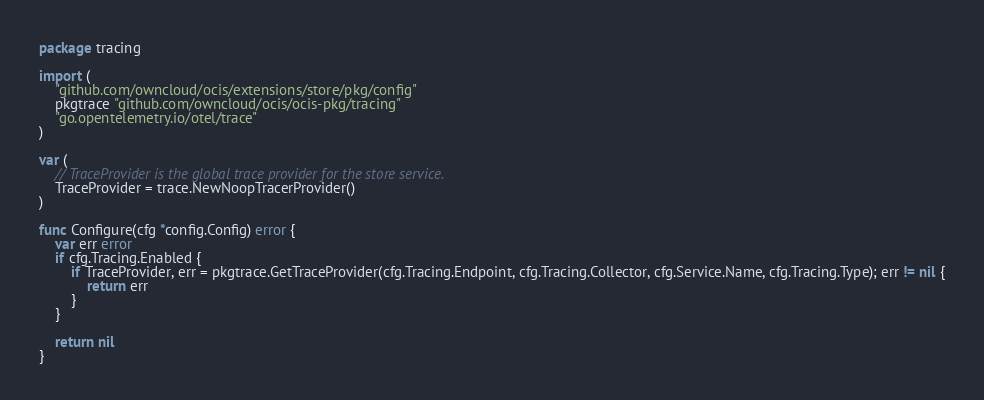Convert code to text. <code><loc_0><loc_0><loc_500><loc_500><_Go_>package tracing

import (
	"github.com/owncloud/ocis/extensions/store/pkg/config"
	pkgtrace "github.com/owncloud/ocis/ocis-pkg/tracing"
	"go.opentelemetry.io/otel/trace"
)

var (
	// TraceProvider is the global trace provider for the store service.
	TraceProvider = trace.NewNoopTracerProvider()
)

func Configure(cfg *config.Config) error {
	var err error
	if cfg.Tracing.Enabled {
		if TraceProvider, err = pkgtrace.GetTraceProvider(cfg.Tracing.Endpoint, cfg.Tracing.Collector, cfg.Service.Name, cfg.Tracing.Type); err != nil {
			return err
		}
	}

	return nil
}
</code> 